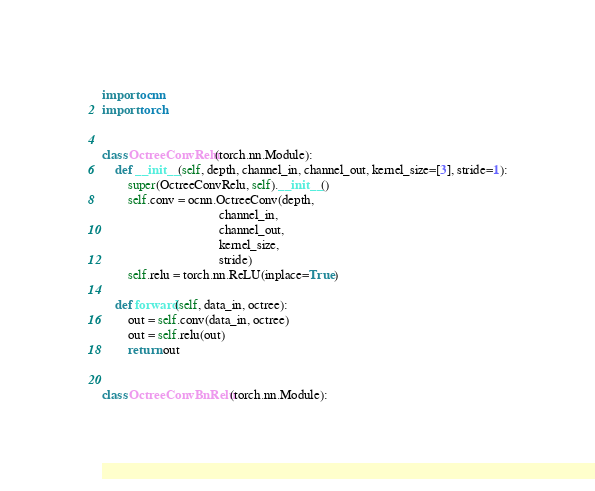<code> <loc_0><loc_0><loc_500><loc_500><_Python_>import ocnn
import torch


class OctreeConvRelu(torch.nn.Module):
    def __init__(self, depth, channel_in, channel_out, kernel_size=[3], stride=1):
        super(OctreeConvRelu, self).__init__()
        self.conv = ocnn.OctreeConv(depth,
                                    channel_in,
                                    channel_out,
                                    kernel_size,
                                    stride)
        self.relu = torch.nn.ReLU(inplace=True)

    def forward(self, data_in, octree):
        out = self.conv(data_in, octree)
        out = self.relu(out)
        return out


class OctreeConvBnRelu(torch.nn.Module):</code> 